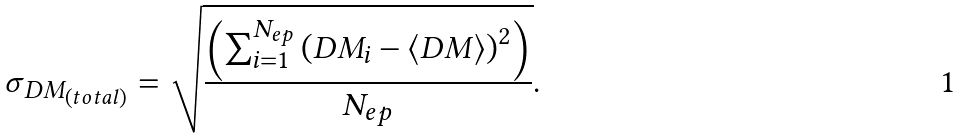<formula> <loc_0><loc_0><loc_500><loc_500>\sigma _ { D M _ { \left ( t o t a l \right ) } } = \sqrt { \frac { \left ( \sum _ { i = 1 } ^ { N _ { e p } } \left ( D M _ { i } - \langle D M \rangle \right ) ^ { 2 } \right ) } { N _ { e p } } } .</formula> 